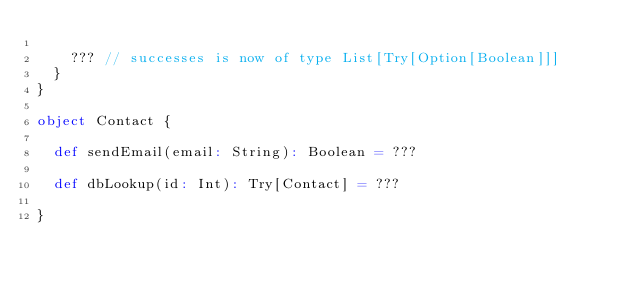Convert code to text. <code><loc_0><loc_0><loc_500><loc_500><_Scala_>
    ??? // successes is now of type List[Try[Option[Boolean]]]
  }
}

object Contact {

  def sendEmail(email: String): Boolean = ???

  def dbLookup(id: Int): Try[Contact] = ???

}

</code> 